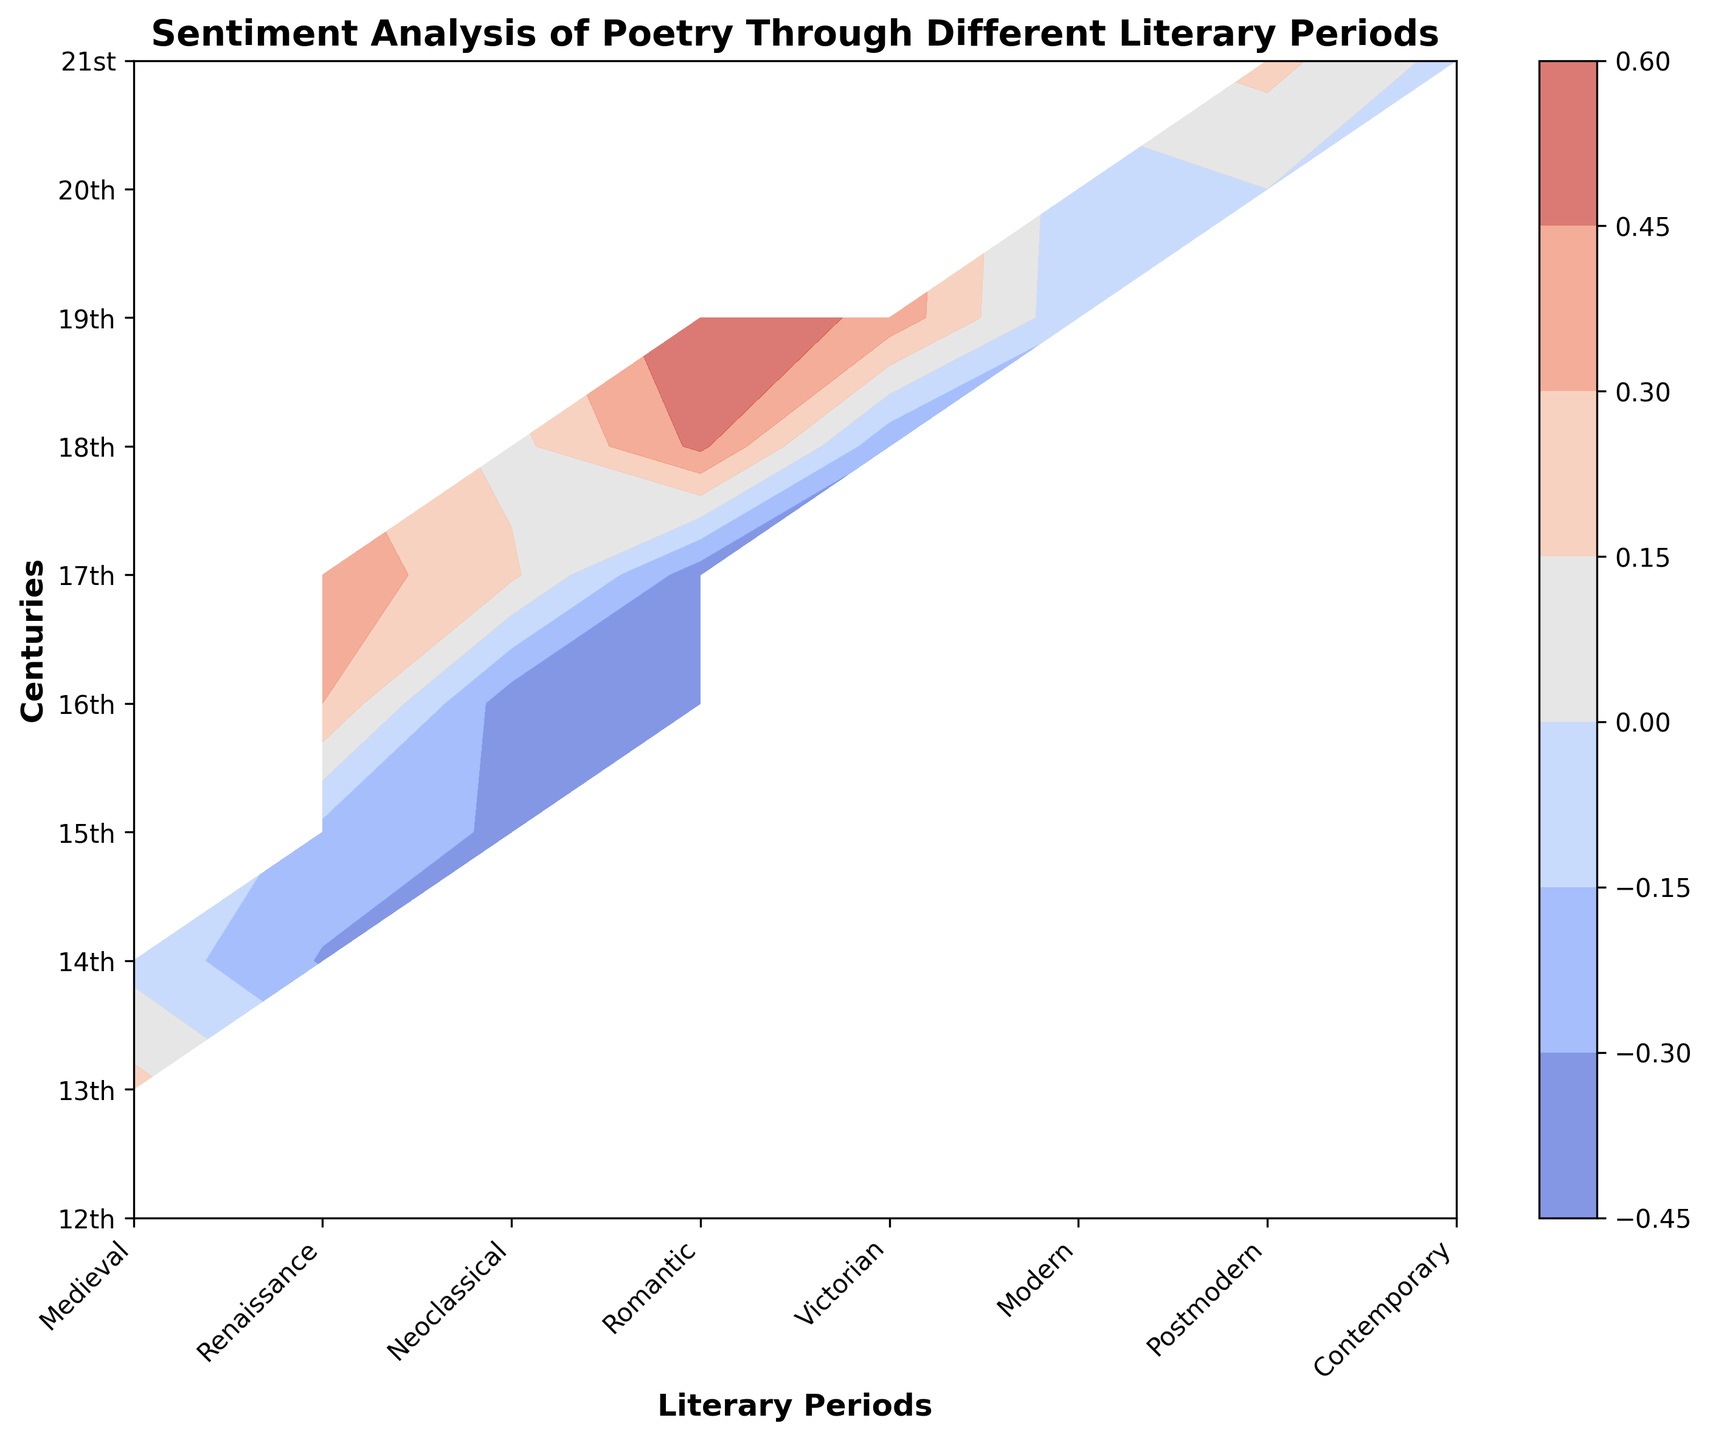When did the Renaissance period show a negative sentiment score? By examining the contour plot, the Renaissance period has negative sentiment scores in the 15th century, as indicated by the contour colors and corresponding values.
Answer: 15th century In which century did the Romantic period show the highest sentiment score? According to the figure, the Romantic period stretches across the 19th century, with the highest sentiment score observed in the middle of the 19th century.
Answer: 19th century Compare the sentiment scores between the Medieval period in the 12th century and the Contemporary period in the 21st century. Which one is lower? By looking at the contour plot, the sentiment score is relatively lower for the Medieval period in the 12th century with a score of -0.1 compared to the Contemporary period in the 21st century, which ranges from -0.05 to 0.15.
Answer: Medieval period in the 12th century What is the average sentiment score for the Modern period? The Modern period includes both the 20th century with an average sentiment score of (0.05 - 0.1 + 0.0)/3 = -0.0167.
Answer: -0.0167 Identify the period and century combination with the highest sentiment score. Examining the contour plot reveals that the Romantic period in the 19th century shows the highest sentiment score of 0.6.
Answer: Romantic period in the 19th century Which century demonstrates the most significant variation in sentiment for the Renaissance period? The Renaissance period shows significant variation in the 16th century with a sentiment score of 0.3 and the 15th century with a score of -0.2.
Answer: 16th century What is the general trend in sentiment scores from the Renaissance period to the Romantic period? Observing the contour plot, there is a general trend of increasing sentiment scores from the Renaissance period (starting with negative scores) to the Romantic period (showing positive scores).
Answer: Increasing How does the sentiment score of the Postmodern period in the 21st century compare with the Victorian period in the 19th century? The Postmodern period in the 21st century has a sentiment score of 0.2, while the Victorian period in the 19th century shows a range of 0.35 to 0.4. Hence, the Victorian period in the 19th century has a higher sentiment score.
Answer: Victorian period in the 19th century Which literary period has the largest range of sentiment scores, and what is this range? The Modern period shows the largest range with scores varying from -0.1 to 0.05, resulting in a range of 0.15.
Answer: Modern period, 0.15 